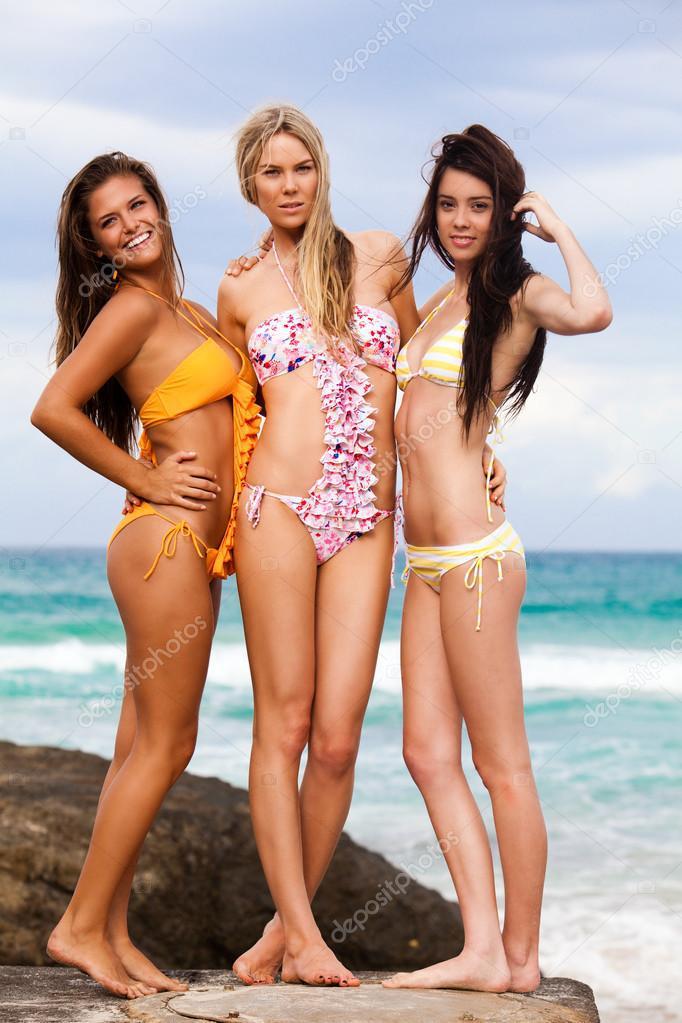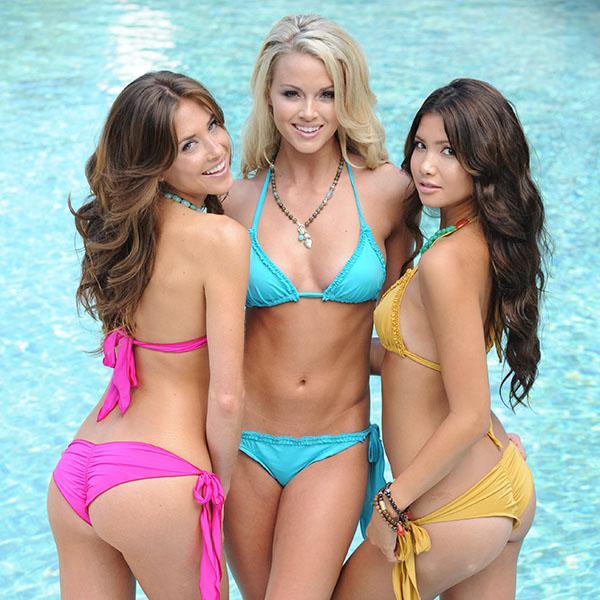The first image is the image on the left, the second image is the image on the right. For the images displayed, is the sentence "An image shows three standing models, each wearing a different solid-colored bikini with matching top and bottom." factually correct? Answer yes or no. Yes. The first image is the image on the left, the second image is the image on the right. For the images displayed, is the sentence "Three women are standing on the shore in the image on the left." factually correct? Answer yes or no. Yes. 